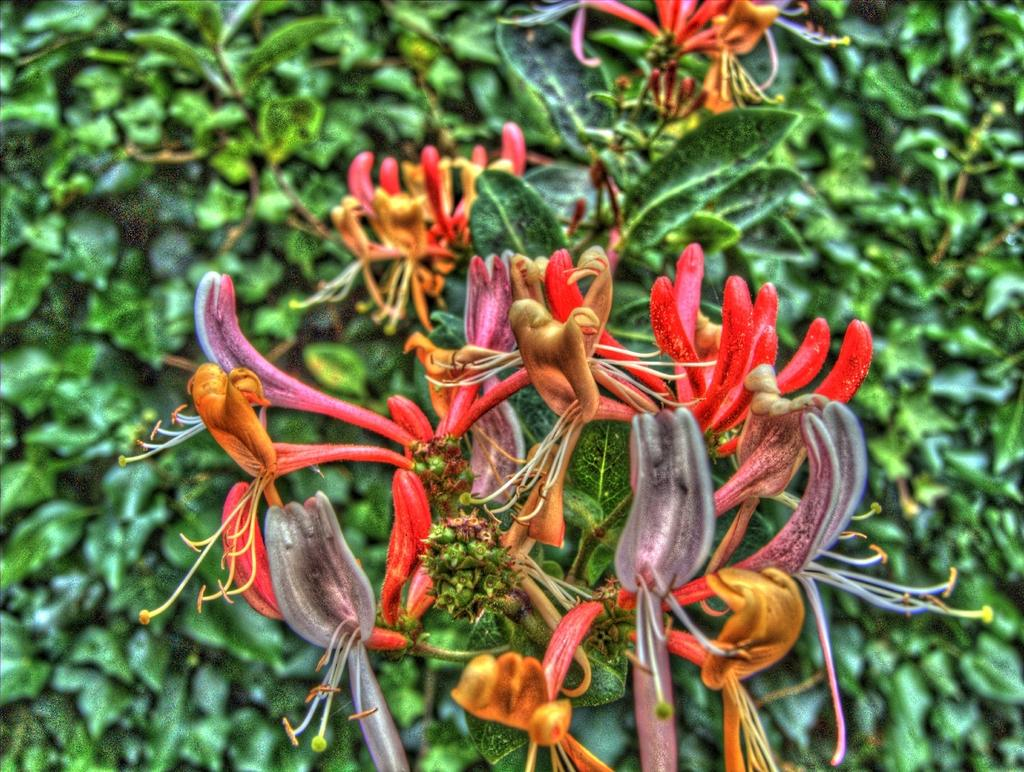What type of plants can be seen in the image? There are flowers in the image. What can be seen in the background of the image? There are leaves in the background of the image. What type of mask is being worn by the flowers in the image? There are no masks present in the image, as it features flowers and leaves. 